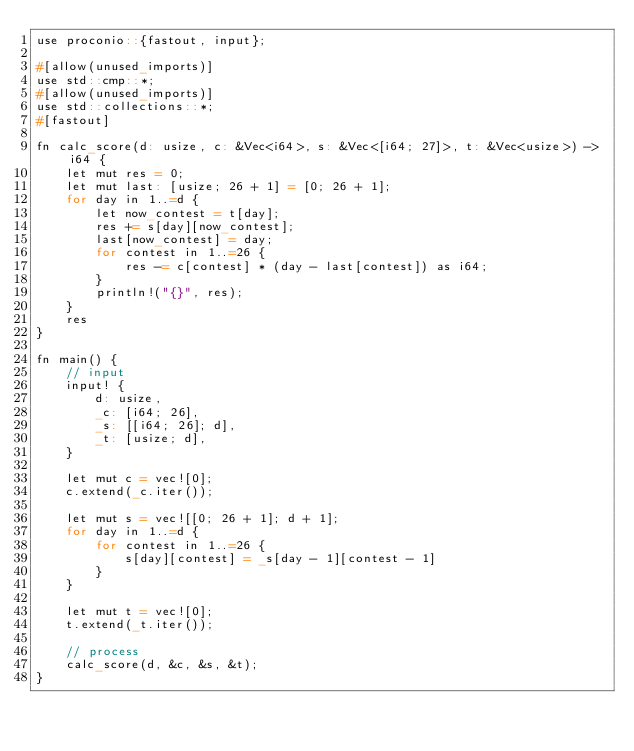<code> <loc_0><loc_0><loc_500><loc_500><_Scala_>use proconio::{fastout, input};

#[allow(unused_imports)]
use std::cmp::*;
#[allow(unused_imports)]
use std::collections::*;
#[fastout]

fn calc_score(d: usize, c: &Vec<i64>, s: &Vec<[i64; 27]>, t: &Vec<usize>) -> i64 {
    let mut res = 0;
    let mut last: [usize; 26 + 1] = [0; 26 + 1];
    for day in 1..=d {
        let now_contest = t[day];
        res += s[day][now_contest];
        last[now_contest] = day;
        for contest in 1..=26 {
            res -= c[contest] * (day - last[contest]) as i64;
        }
        println!("{}", res);
    }
    res
}

fn main() {
    // input
    input! {
        d: usize,
        _c: [i64; 26],
        _s: [[i64; 26]; d],
        _t: [usize; d],
    }

    let mut c = vec![0];
    c.extend(_c.iter());

    let mut s = vec![[0; 26 + 1]; d + 1];
    for day in 1..=d {
        for contest in 1..=26 {
            s[day][contest] = _s[day - 1][contest - 1]
        }
    }

    let mut t = vec![0];
    t.extend(_t.iter());

    // process
    calc_score(d, &c, &s, &t);
}
</code> 